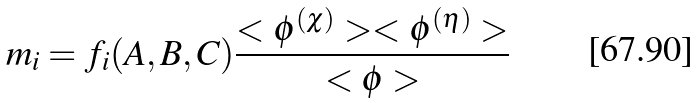Convert formula to latex. <formula><loc_0><loc_0><loc_500><loc_500>m _ { i } = f _ { i } ( A , B , C ) \frac { < \phi ^ { ( \chi ) } > < \phi ^ { ( \eta ) } > } { < \phi > }</formula> 